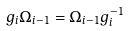Convert formula to latex. <formula><loc_0><loc_0><loc_500><loc_500>g _ { i } \Omega _ { i - 1 } = \Omega _ { i - 1 } g _ { i } ^ { - 1 }</formula> 